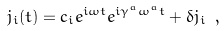Convert formula to latex. <formula><loc_0><loc_0><loc_500><loc_500>j _ { i } ( t ) = c _ { i } e ^ { i \omega t } e ^ { i \gamma ^ { a } \omega ^ { a } t } + \delta j _ { i } \ ,</formula> 